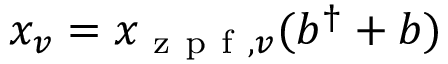Convert formula to latex. <formula><loc_0><loc_0><loc_500><loc_500>x _ { v } = { x _ { z p f , v } } ( b ^ { \dagger } + b )</formula> 